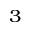Convert formula to latex. <formula><loc_0><loc_0><loc_500><loc_500>^ { 3 }</formula> 